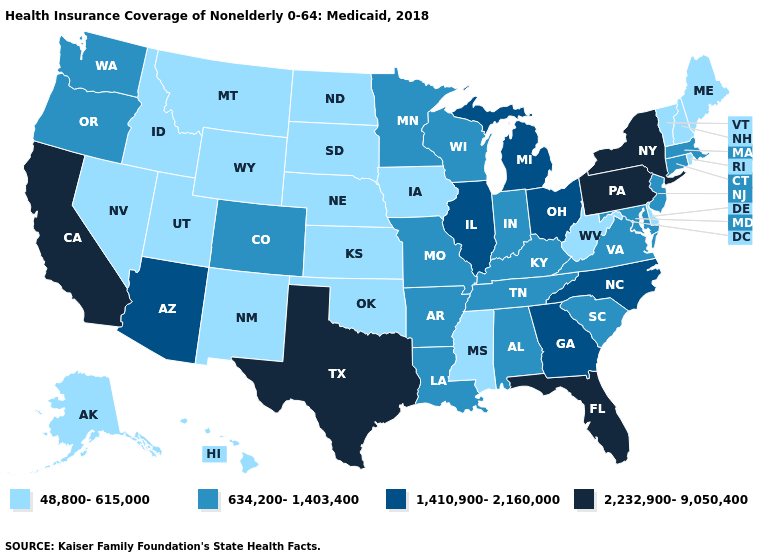What is the highest value in states that border Wisconsin?
Give a very brief answer. 1,410,900-2,160,000. What is the value of Wyoming?
Be succinct. 48,800-615,000. What is the lowest value in the MidWest?
Keep it brief. 48,800-615,000. Among the states that border Delaware , does New Jersey have the highest value?
Concise answer only. No. What is the value of Colorado?
Be succinct. 634,200-1,403,400. Does Alaska have the highest value in the West?
Write a very short answer. No. Name the states that have a value in the range 48,800-615,000?
Be succinct. Alaska, Delaware, Hawaii, Idaho, Iowa, Kansas, Maine, Mississippi, Montana, Nebraska, Nevada, New Hampshire, New Mexico, North Dakota, Oklahoma, Rhode Island, South Dakota, Utah, Vermont, West Virginia, Wyoming. Does Wyoming have the highest value in the USA?
Short answer required. No. What is the lowest value in the West?
Write a very short answer. 48,800-615,000. Name the states that have a value in the range 48,800-615,000?
Give a very brief answer. Alaska, Delaware, Hawaii, Idaho, Iowa, Kansas, Maine, Mississippi, Montana, Nebraska, Nevada, New Hampshire, New Mexico, North Dakota, Oklahoma, Rhode Island, South Dakota, Utah, Vermont, West Virginia, Wyoming. Does Florida have the highest value in the USA?
Give a very brief answer. Yes. Name the states that have a value in the range 1,410,900-2,160,000?
Answer briefly. Arizona, Georgia, Illinois, Michigan, North Carolina, Ohio. Among the states that border New York , does Pennsylvania have the highest value?
Give a very brief answer. Yes. Name the states that have a value in the range 48,800-615,000?
Keep it brief. Alaska, Delaware, Hawaii, Idaho, Iowa, Kansas, Maine, Mississippi, Montana, Nebraska, Nevada, New Hampshire, New Mexico, North Dakota, Oklahoma, Rhode Island, South Dakota, Utah, Vermont, West Virginia, Wyoming. Does the first symbol in the legend represent the smallest category?
Answer briefly. Yes. 